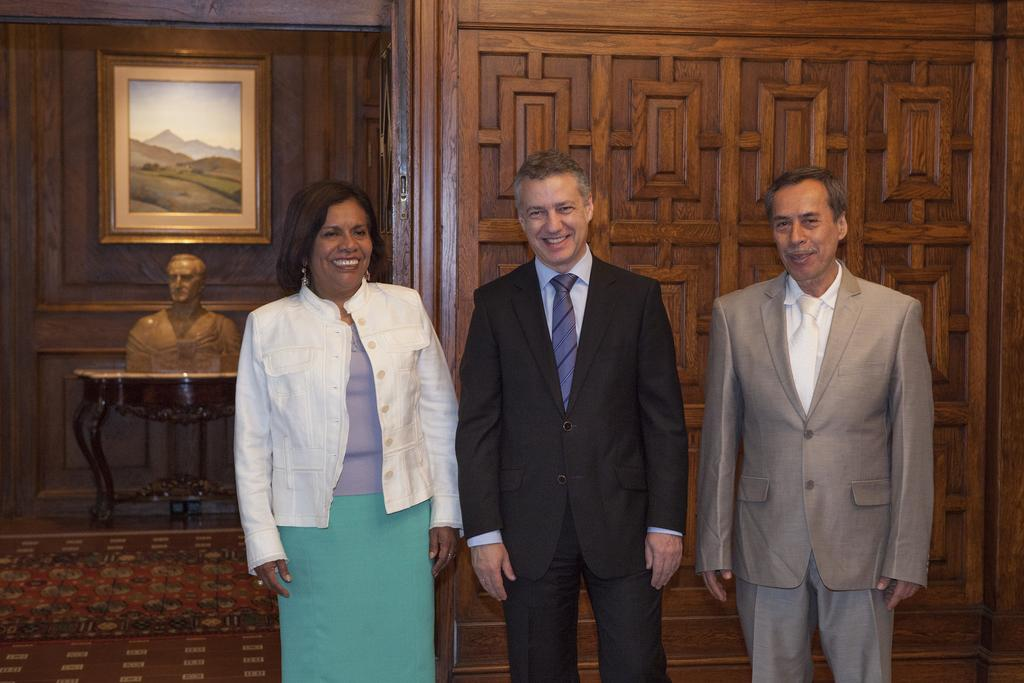How many people are in the foreground of the picture? There are two men and a woman in the foreground of the picture. What can be seen on the left side of the image? There is a statue, a desk, and a frame on the left side of the image. What type of wall is visible in the background of the image? There is a wooden wall visible in the background of the image. How does the guide help the people in the image? There is no guide present in the image; it only features two men and a woman in the foreground, a statue, a desk, and a frame on the left side, and a wooden wall in the background. 